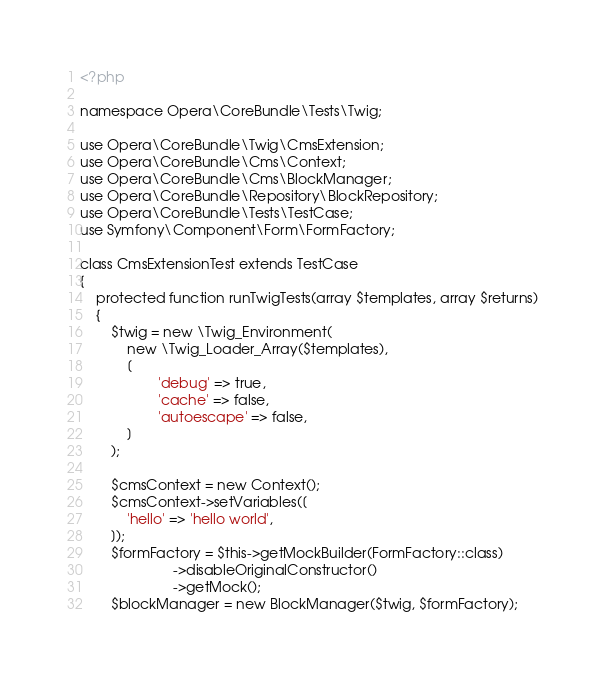<code> <loc_0><loc_0><loc_500><loc_500><_PHP_><?php

namespace Opera\CoreBundle\Tests\Twig;

use Opera\CoreBundle\Twig\CmsExtension;
use Opera\CoreBundle\Cms\Context;
use Opera\CoreBundle\Cms\BlockManager;
use Opera\CoreBundle\Repository\BlockRepository;
use Opera\CoreBundle\Tests\TestCase;
use Symfony\Component\Form\FormFactory;

class CmsExtensionTest extends TestCase
{
    protected function runTwigTests(array $templates, array $returns)
    {
        $twig = new \Twig_Environment(
            new \Twig_Loader_Array($templates),
            [
                    'debug' => true,
                    'cache' => false,
                    'autoescape' => false,
            ]
        );

        $cmsContext = new Context();
        $cmsContext->setVariables([
            'hello' => 'hello world',
        ]);
        $formFactory = $this->getMockBuilder(FormFactory::class)
                        ->disableOriginalConstructor()
                        ->getMock();
        $blockManager = new BlockManager($twig, $formFactory);</code> 